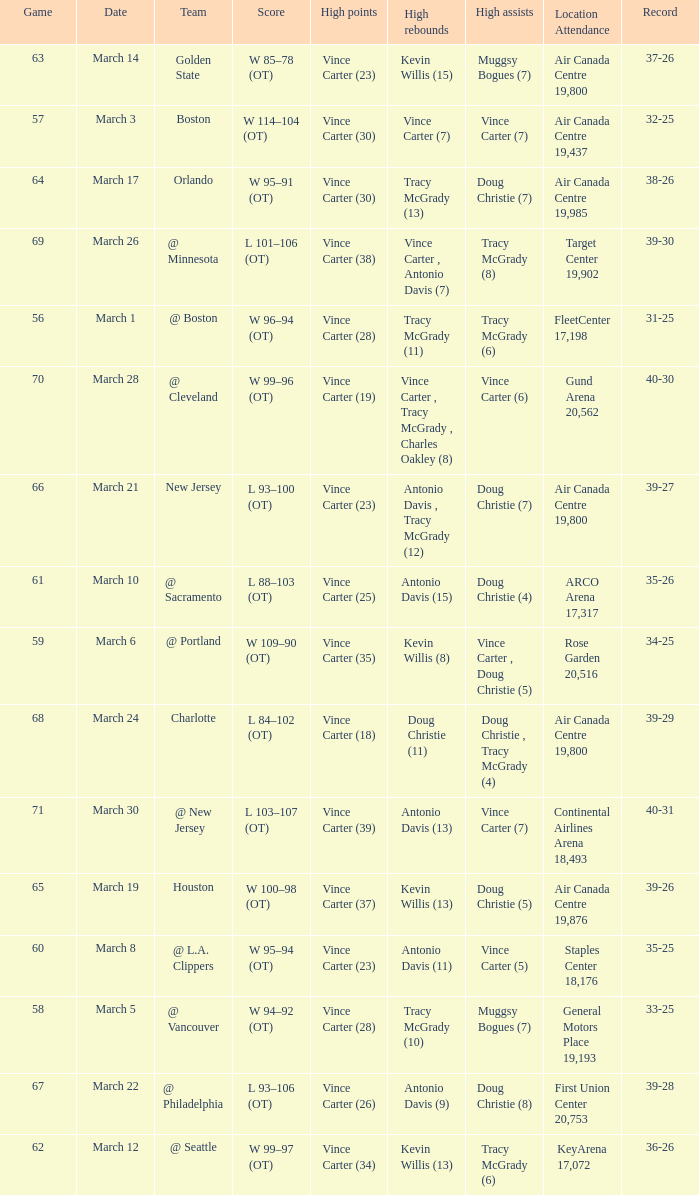Who was the high rebounder against charlotte? Doug Christie (11). 